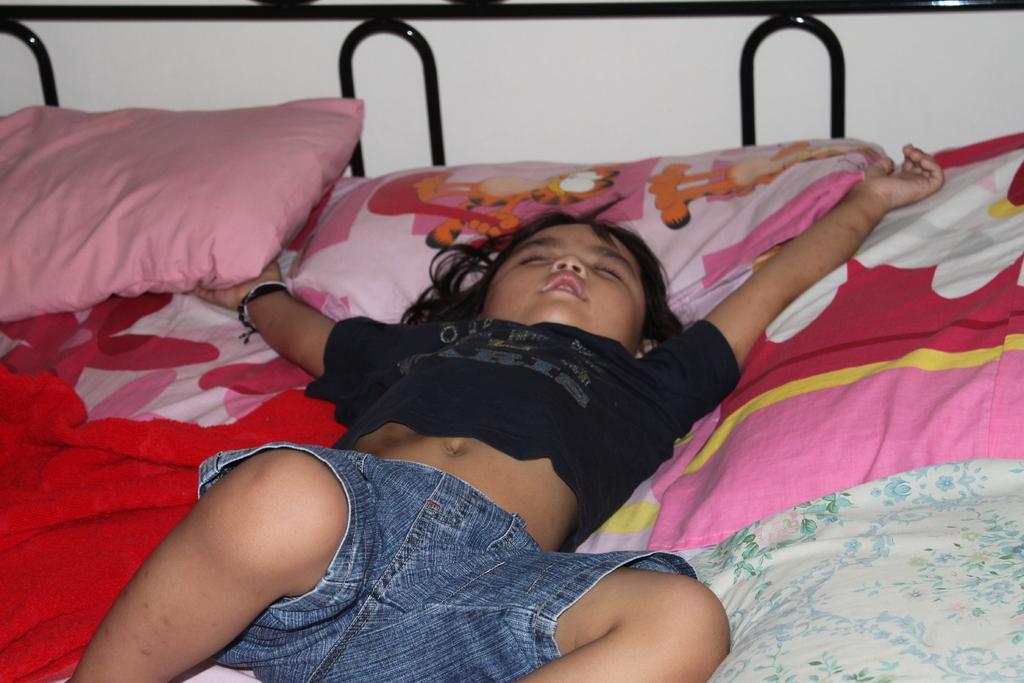How would you summarize this image in a sentence or two? In this picture we can see a girl in black shirt and blue short sleeping on the bed on which there are some pillows and bed sheet in pink, yellow,orange and white color. 